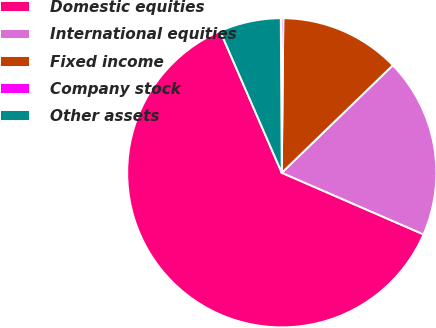Convert chart. <chart><loc_0><loc_0><loc_500><loc_500><pie_chart><fcel>Domestic equities<fcel>International equities<fcel>Fixed income<fcel>Company stock<fcel>Other assets<nl><fcel>61.94%<fcel>18.77%<fcel>12.6%<fcel>0.26%<fcel>6.43%<nl></chart> 